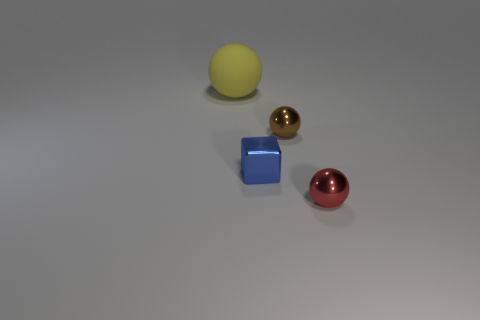Do the yellow rubber thing and the metal thing behind the tiny blue metal block have the same shape?
Provide a short and direct response. Yes. Is there anything else that is the same material as the large thing?
Provide a short and direct response. No. There is a small red thing that is the same shape as the brown thing; what is its material?
Offer a terse response. Metal. What number of small things are either blue spheres or brown metal spheres?
Keep it short and to the point. 1. Are there fewer large yellow spheres that are to the right of the red object than small blue shiny things on the right side of the small brown shiny ball?
Ensure brevity in your answer.  No. What number of things are large spheres or tiny red shiny balls?
Provide a succinct answer. 2. There is a small brown metallic thing; what number of tiny shiny things are on the left side of it?
Give a very brief answer. 1. What is the shape of the small brown object that is the same material as the red thing?
Make the answer very short. Sphere. Is the shape of the brown shiny thing right of the small block the same as  the tiny red object?
Ensure brevity in your answer.  Yes. What number of green things are either balls or small blocks?
Keep it short and to the point. 0. 